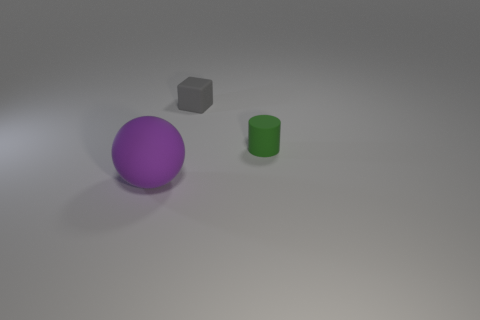Is there anything else that is the same size as the matte sphere?
Ensure brevity in your answer.  No. The other tiny object that is made of the same material as the small green thing is what color?
Offer a terse response. Gray. There is a small object behind the small thing on the right side of the small object that is on the left side of the tiny rubber cylinder; what color is it?
Ensure brevity in your answer.  Gray. Is the size of the green cylinder the same as the purple thing to the left of the rubber cylinder?
Ensure brevity in your answer.  No. What number of objects are either rubber objects that are behind the large sphere or objects that are in front of the block?
Your response must be concise. 3. What shape is the green rubber object that is the same size as the gray matte thing?
Provide a short and direct response. Cylinder. There is a tiny rubber object left of the rubber thing that is on the right side of the matte thing behind the green object; what shape is it?
Your response must be concise. Cube. Are there the same number of tiny gray objects in front of the tiny gray object and objects?
Offer a very short reply. No. Does the ball have the same size as the rubber cylinder?
Provide a short and direct response. No. What number of matte objects are either large red blocks or large spheres?
Your answer should be compact. 1. 